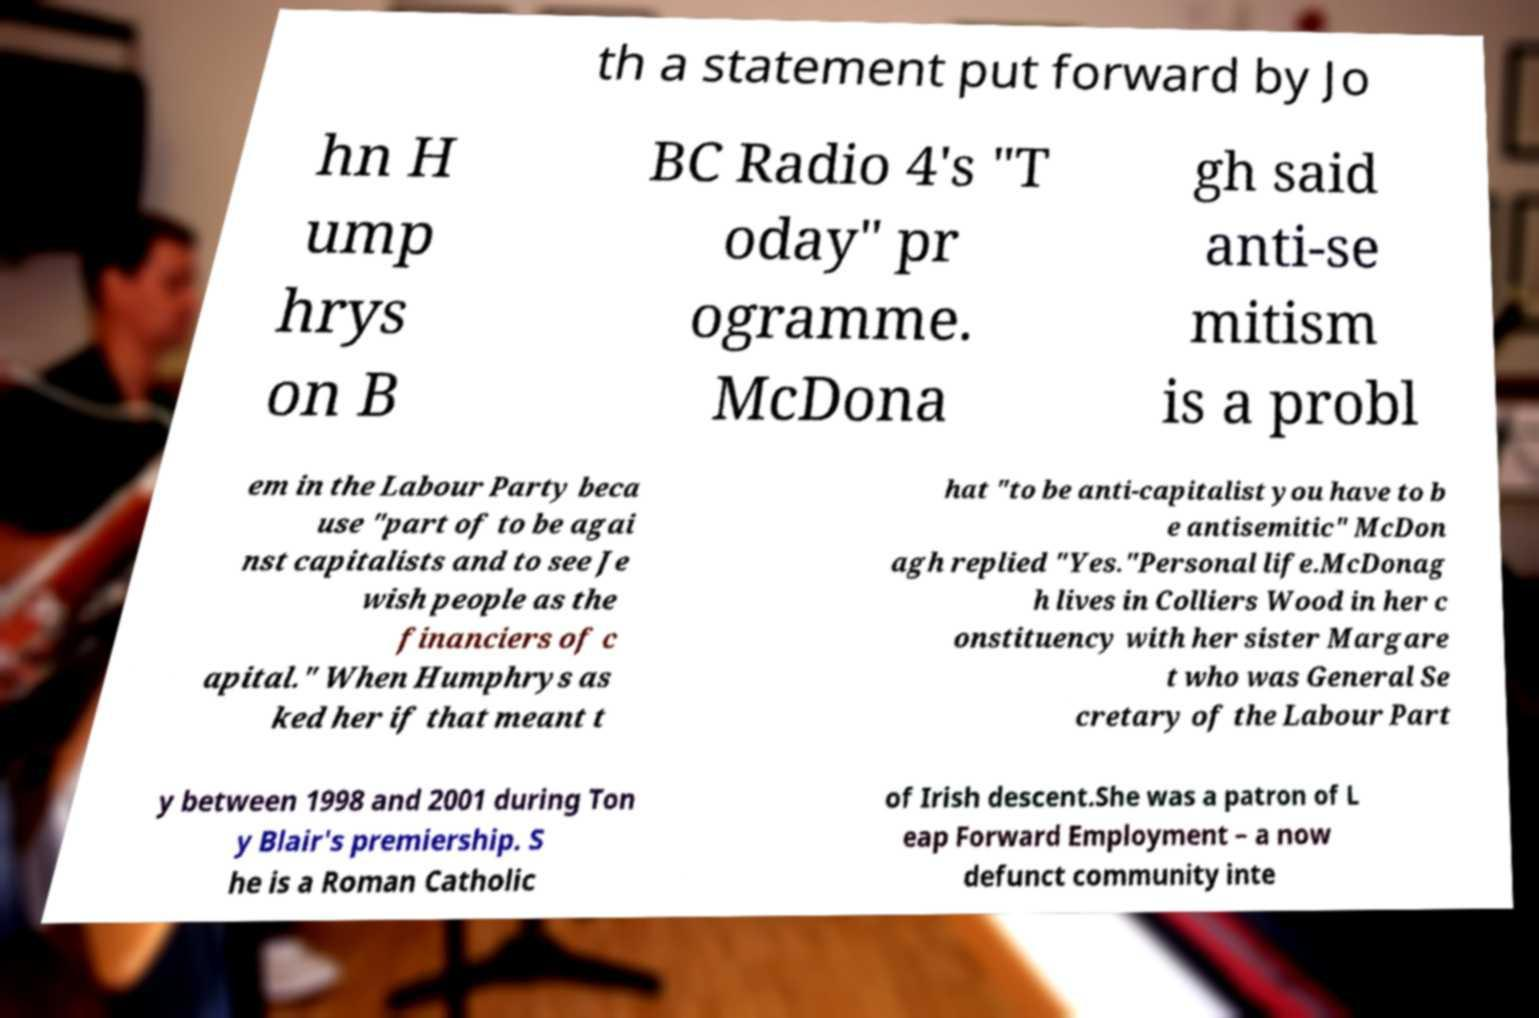There's text embedded in this image that I need extracted. Can you transcribe it verbatim? th a statement put forward by Jo hn H ump hrys on B BC Radio 4's "T oday" pr ogramme. McDona gh said anti-se mitism is a probl em in the Labour Party beca use "part of to be agai nst capitalists and to see Je wish people as the financiers of c apital." When Humphrys as ked her if that meant t hat "to be anti-capitalist you have to b e antisemitic" McDon agh replied "Yes."Personal life.McDonag h lives in Colliers Wood in her c onstituency with her sister Margare t who was General Se cretary of the Labour Part y between 1998 and 2001 during Ton y Blair's premiership. S he is a Roman Catholic of Irish descent.She was a patron of L eap Forward Employment – a now defunct community inte 